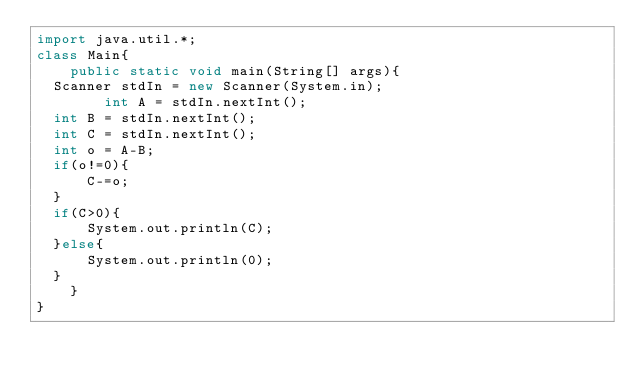Convert code to text. <code><loc_0><loc_0><loc_500><loc_500><_Java_>import java.util.*;
class Main{
    public static void main(String[] args){
	Scanner stdIn = new Scanner(System.in);
        int A = stdIn.nextInt();
	int B = stdIn.nextInt();
	int C = stdIn.nextInt();
	int o = A-B;
	if(o!=0){
	    C-=o;
	}
	if(C>0){
	    System.out.println(C);
	}else{
	    System.out.println(0);
	}
    }
}
</code> 